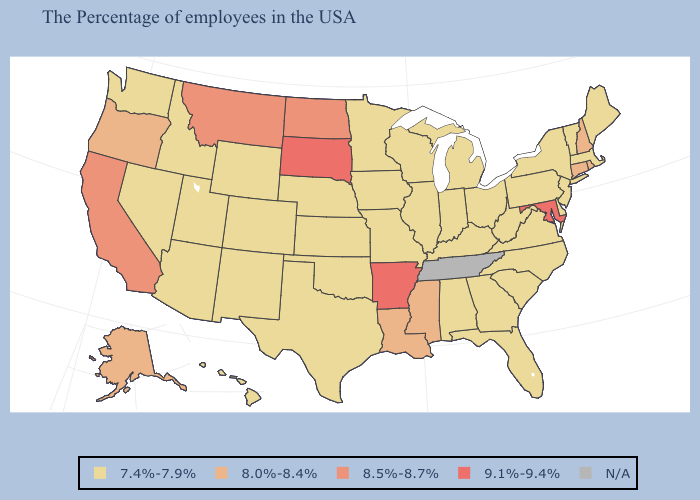Name the states that have a value in the range N/A?
Short answer required. Tennessee. Which states have the highest value in the USA?
Short answer required. Maryland, Arkansas, South Dakota. What is the value of New Mexico?
Keep it brief. 7.4%-7.9%. What is the highest value in the West ?
Give a very brief answer. 8.5%-8.7%. Does the first symbol in the legend represent the smallest category?
Answer briefly. Yes. Among the states that border Iowa , does South Dakota have the lowest value?
Write a very short answer. No. What is the value of Texas?
Give a very brief answer. 7.4%-7.9%. Name the states that have a value in the range 7.4%-7.9%?
Concise answer only. Maine, Massachusetts, Vermont, New York, New Jersey, Delaware, Pennsylvania, Virginia, North Carolina, South Carolina, West Virginia, Ohio, Florida, Georgia, Michigan, Kentucky, Indiana, Alabama, Wisconsin, Illinois, Missouri, Minnesota, Iowa, Kansas, Nebraska, Oklahoma, Texas, Wyoming, Colorado, New Mexico, Utah, Arizona, Idaho, Nevada, Washington, Hawaii. What is the highest value in the Northeast ?
Short answer required. 8.0%-8.4%. What is the highest value in states that border North Carolina?
Be succinct. 7.4%-7.9%. Name the states that have a value in the range N/A?
Keep it brief. Tennessee. Does the map have missing data?
Write a very short answer. Yes. Which states have the highest value in the USA?
Short answer required. Maryland, Arkansas, South Dakota. What is the lowest value in the MidWest?
Keep it brief. 7.4%-7.9%. 